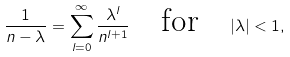<formula> <loc_0><loc_0><loc_500><loc_500>\frac { 1 } { n - \lambda } = \sum _ { l = 0 } ^ { \infty } \frac { \lambda ^ { l } } { n ^ { l + 1 } } \quad \text {for} \quad | \lambda | < 1 ,</formula> 